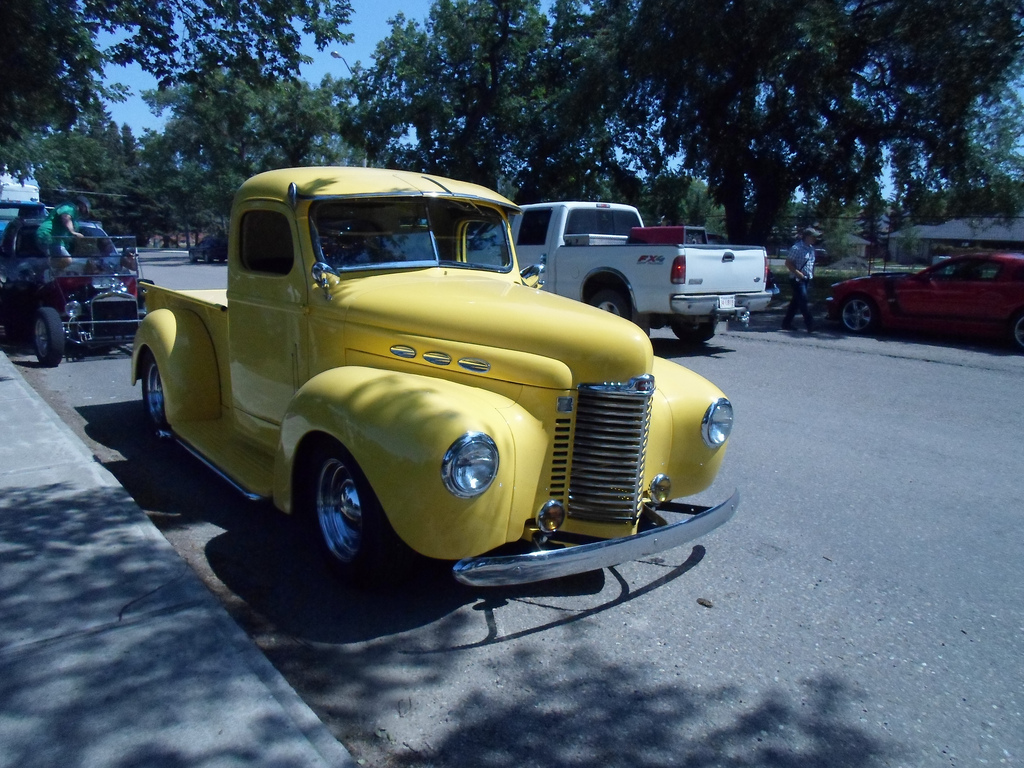What vehicle is to the right of the man? To the right of the man stands a classic red car, possibly from the 1960s, reflecting the vintage tone of the scene. 